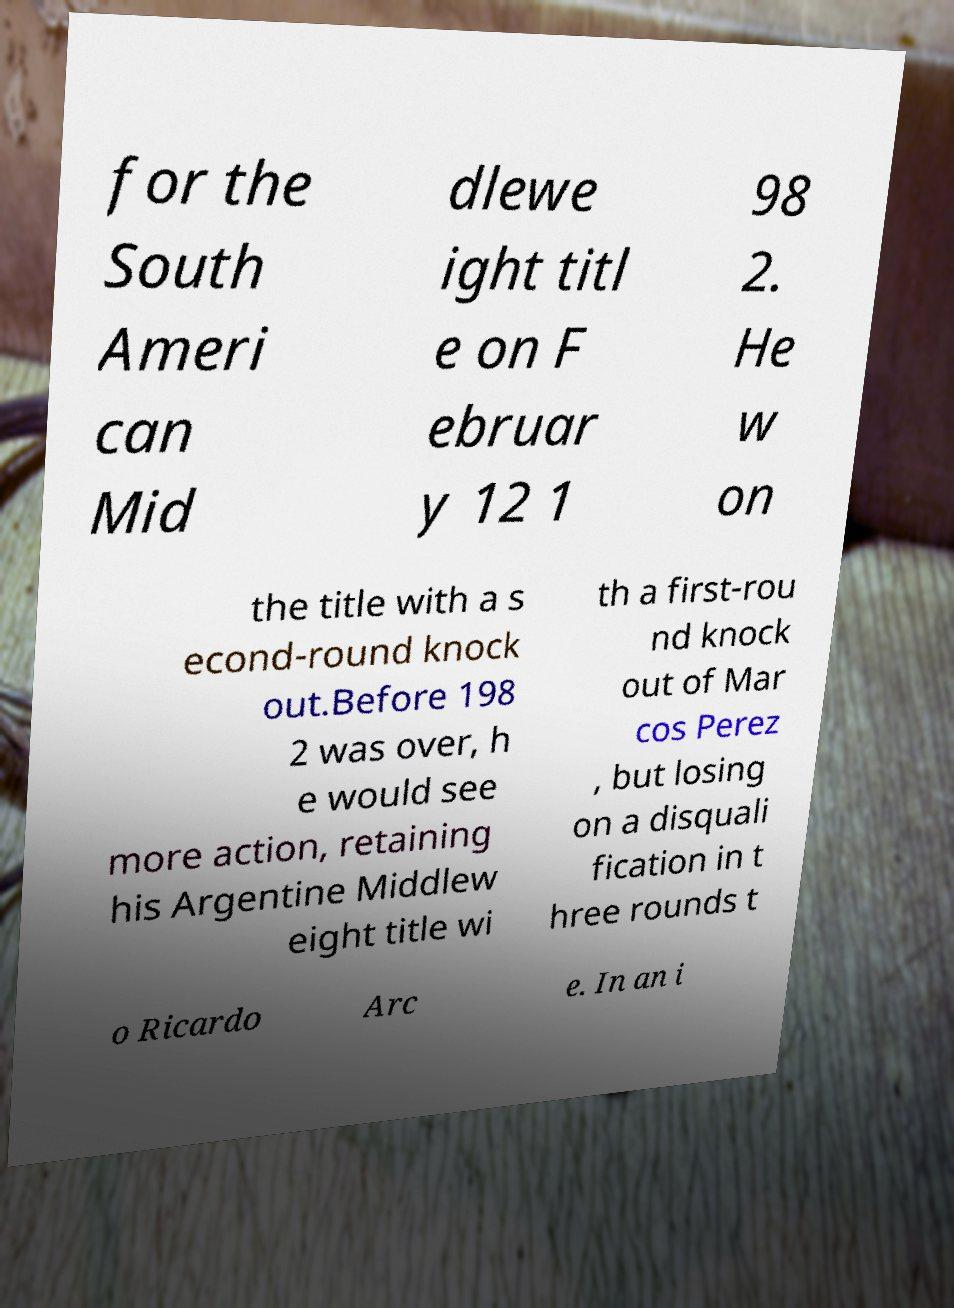Please identify and transcribe the text found in this image. for the South Ameri can Mid dlewe ight titl e on F ebruar y 12 1 98 2. He w on the title with a s econd-round knock out.Before 198 2 was over, h e would see more action, retaining his Argentine Middlew eight title wi th a first-rou nd knock out of Mar cos Perez , but losing on a disquali fication in t hree rounds t o Ricardo Arc e. In an i 